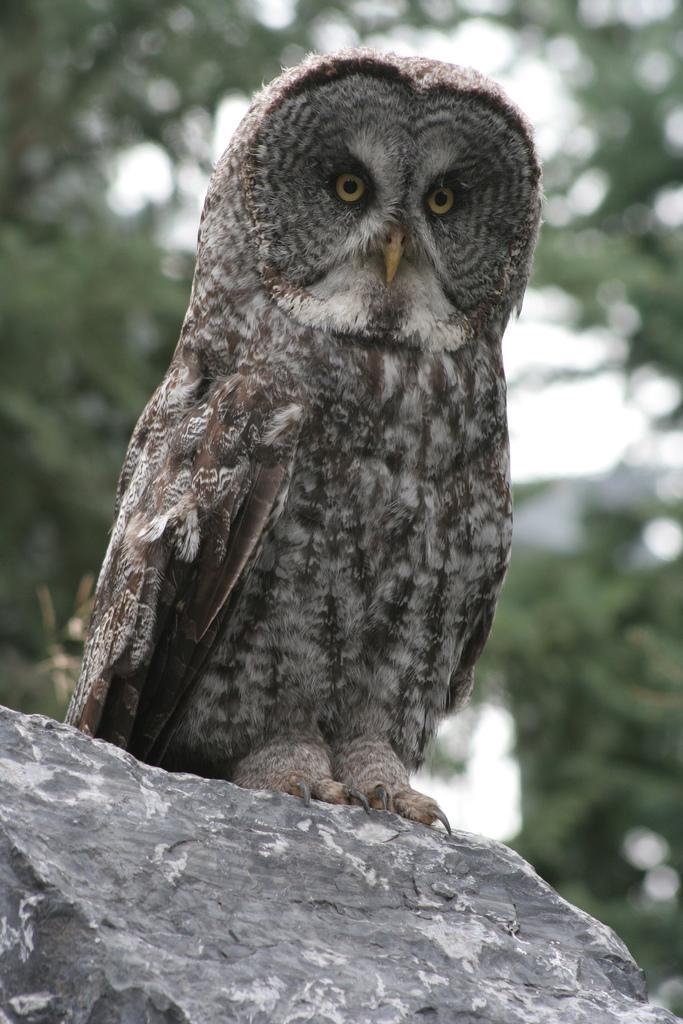How would you summarize this image in a sentence or two? In this image I can see an owl on the rock. In the background I can see few trees in green color and the sky is in white color. 